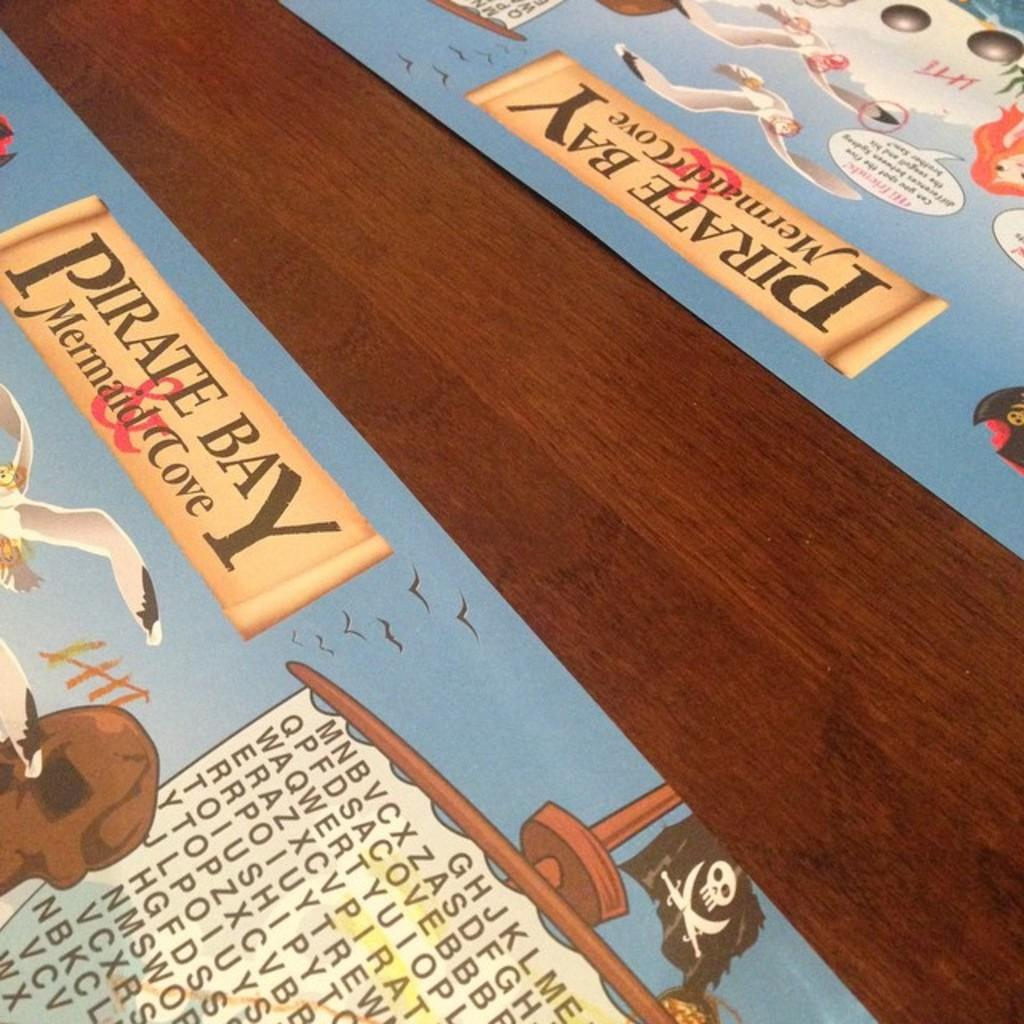<image>
Share a concise interpretation of the image provided. two paper place mats for the pirate bay mermaid cove 